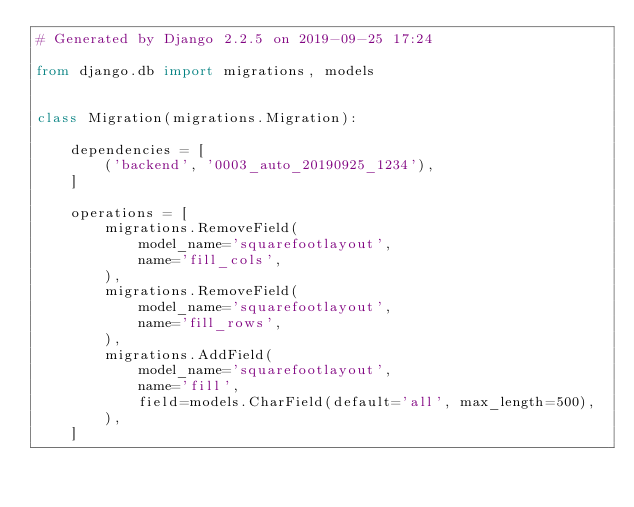Convert code to text. <code><loc_0><loc_0><loc_500><loc_500><_Python_># Generated by Django 2.2.5 on 2019-09-25 17:24

from django.db import migrations, models


class Migration(migrations.Migration):

    dependencies = [
        ('backend', '0003_auto_20190925_1234'),
    ]

    operations = [
        migrations.RemoveField(
            model_name='squarefootlayout',
            name='fill_cols',
        ),
        migrations.RemoveField(
            model_name='squarefootlayout',
            name='fill_rows',
        ),
        migrations.AddField(
            model_name='squarefootlayout',
            name='fill',
            field=models.CharField(default='all', max_length=500),
        ),
    ]
</code> 